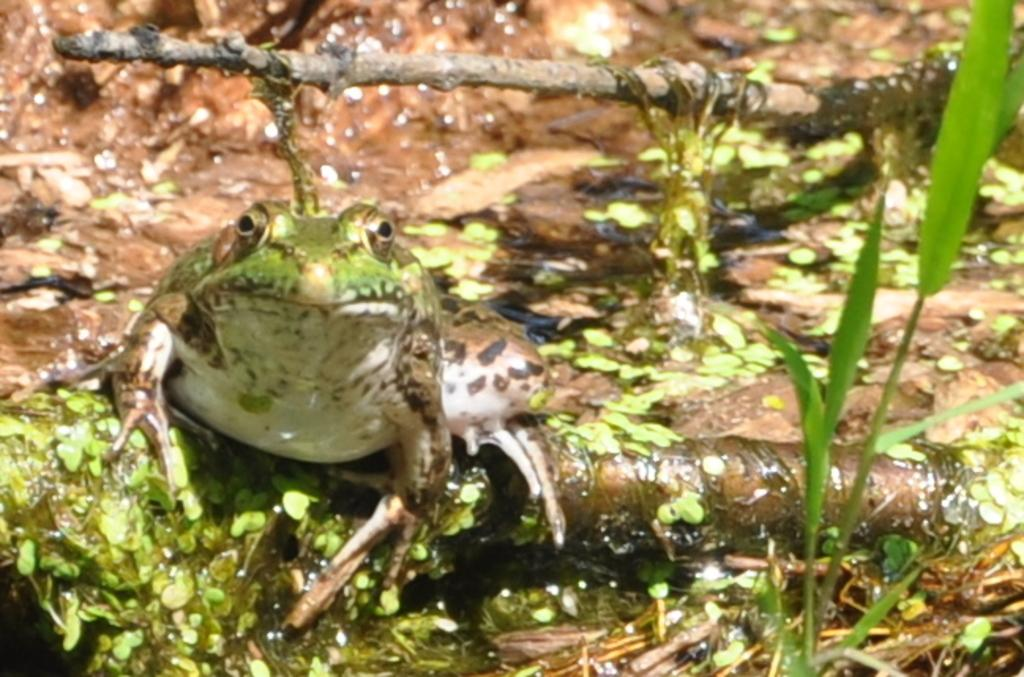What animal is present in the image? There is a frog in the image. What is the frog sitting on? The frog is sitting on wood. What other living organism can be seen in the image? There is a plant in the image. Can you describe the background of the image? The background of the image is blurry. What type of chain can be seen hanging from the frog's mouth in the image? There is no chain present in the image, and the frog is not depicted with anything hanging from its mouth. 